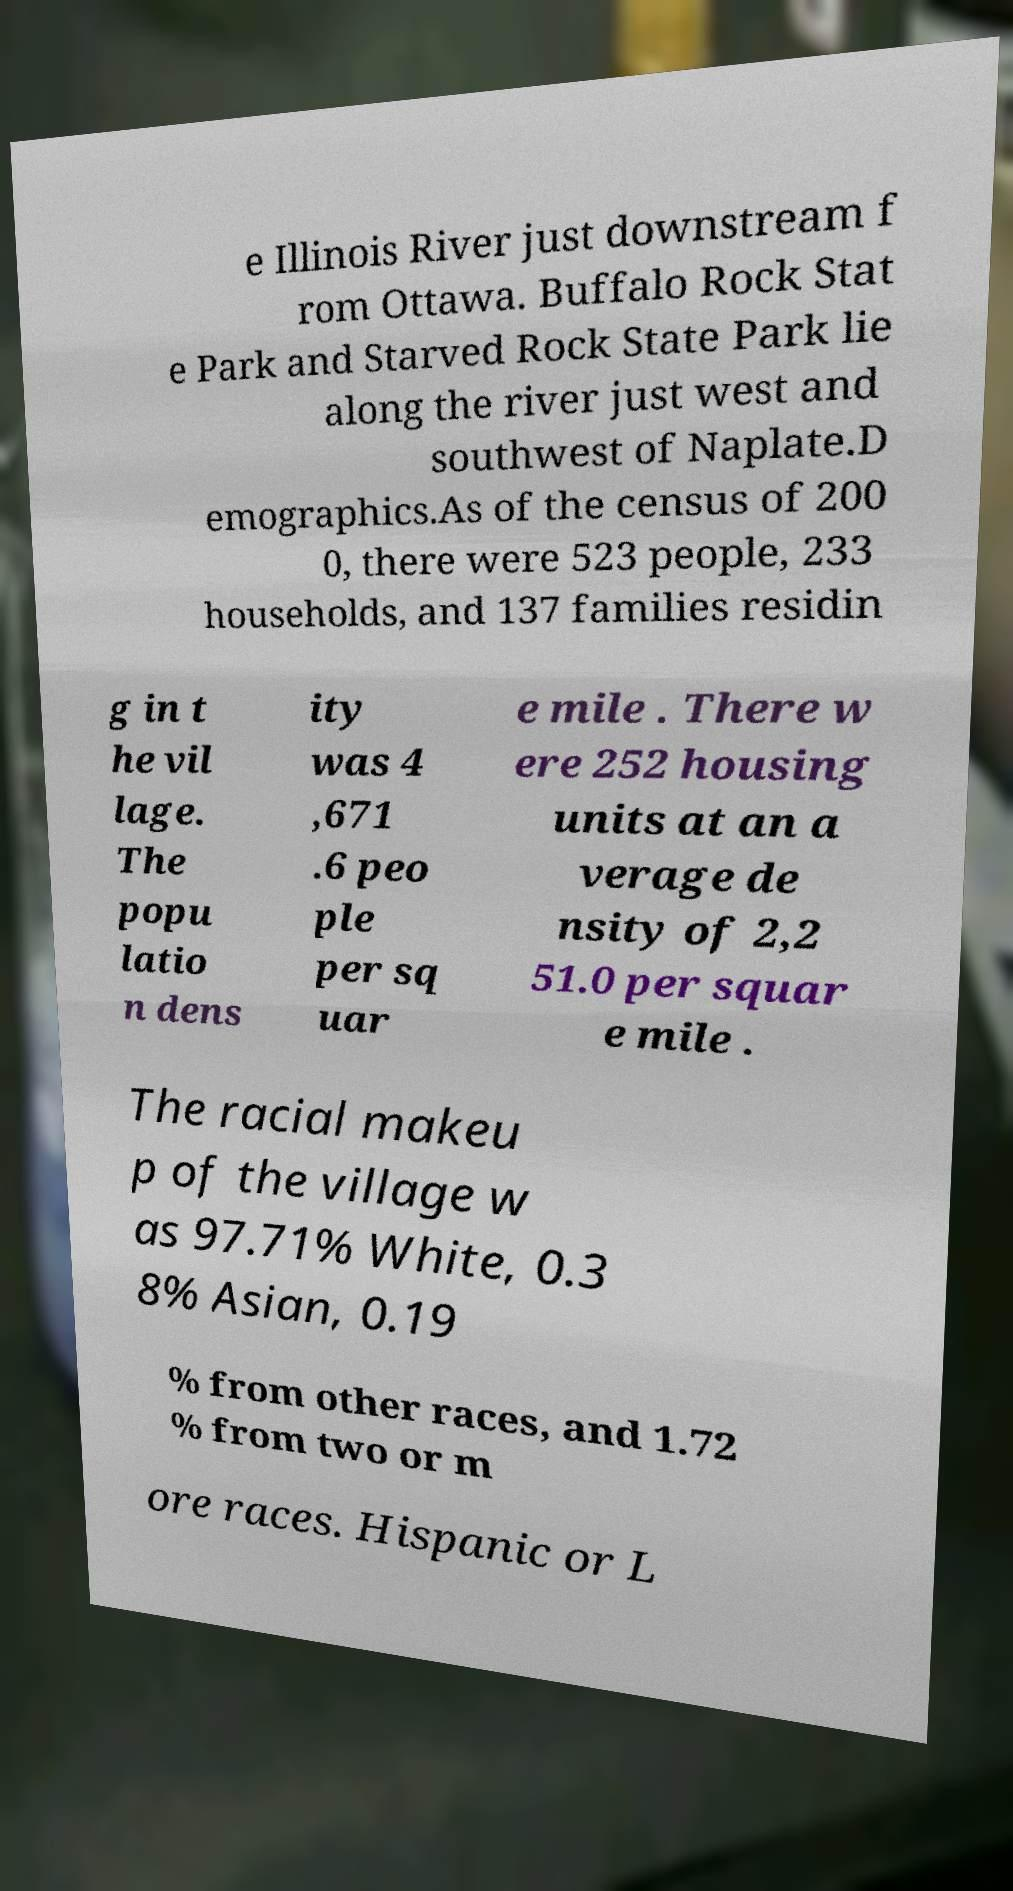There's text embedded in this image that I need extracted. Can you transcribe it verbatim? e Illinois River just downstream f rom Ottawa. Buffalo Rock Stat e Park and Starved Rock State Park lie along the river just west and southwest of Naplate.D emographics.As of the census of 200 0, there were 523 people, 233 households, and 137 families residin g in t he vil lage. The popu latio n dens ity was 4 ,671 .6 peo ple per sq uar e mile . There w ere 252 housing units at an a verage de nsity of 2,2 51.0 per squar e mile . The racial makeu p of the village w as 97.71% White, 0.3 8% Asian, 0.19 % from other races, and 1.72 % from two or m ore races. Hispanic or L 